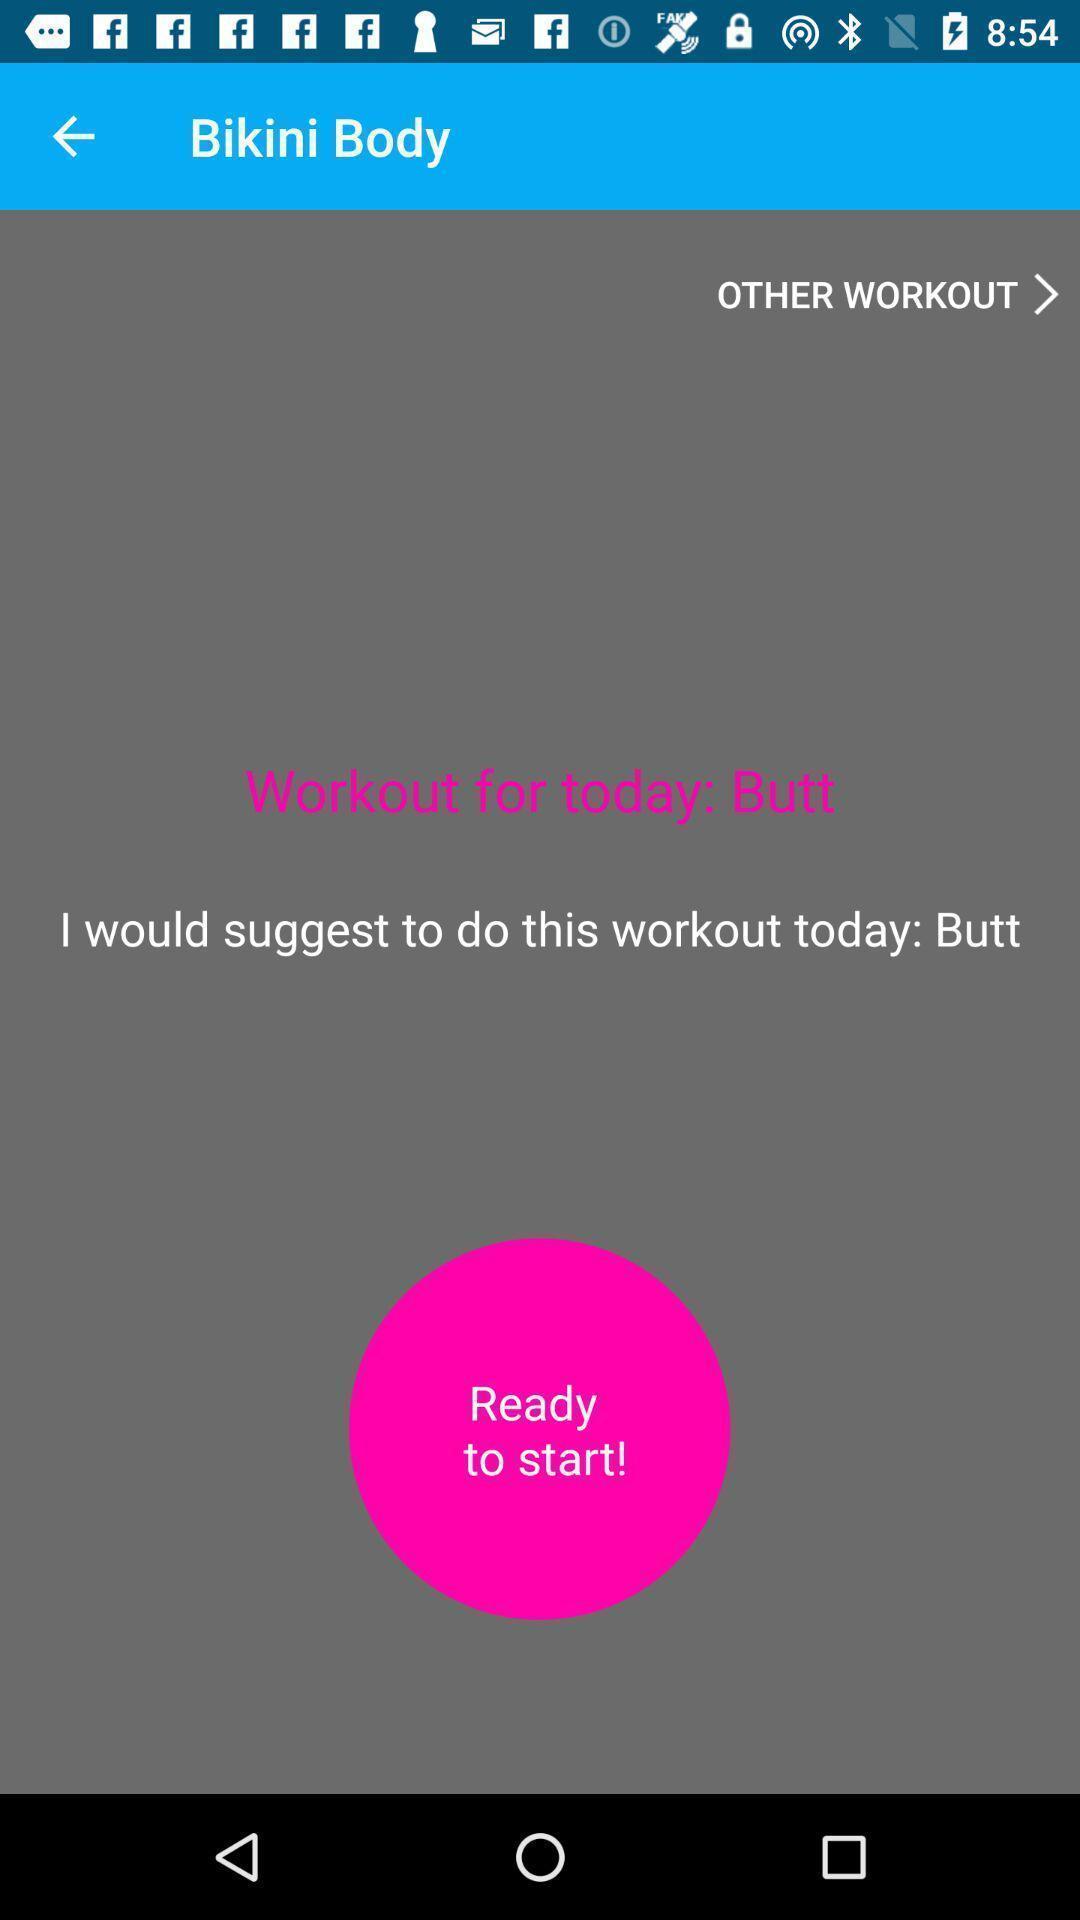Please provide a description for this image. Screen displaying of exercise application. 